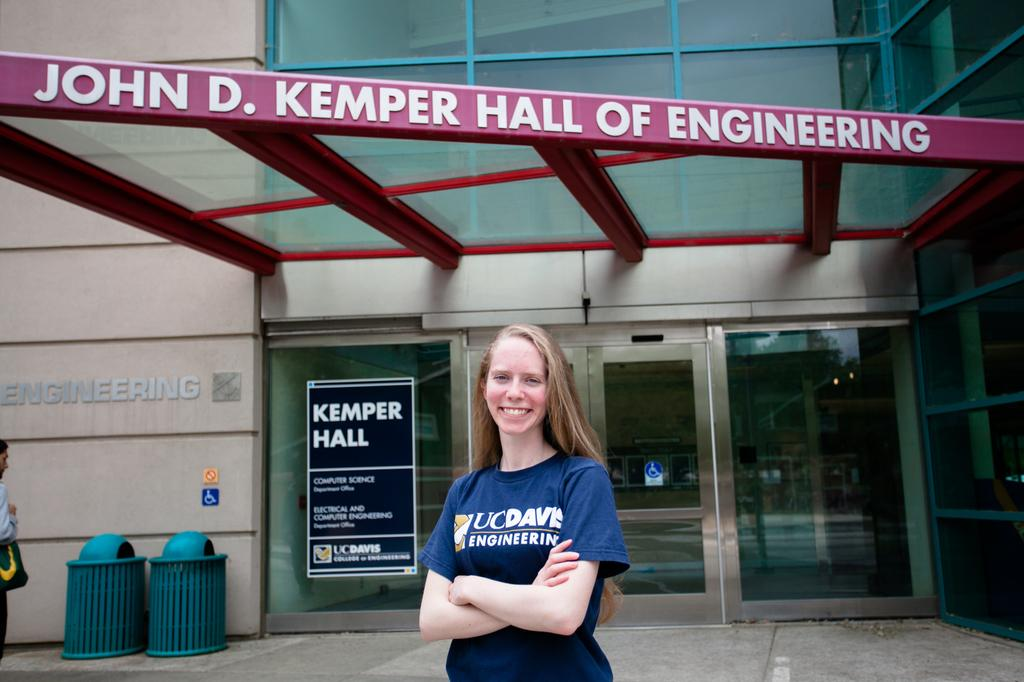<image>
Describe the image concisely. Girl is standing in front of John D. Kemper Hall of Engineering 